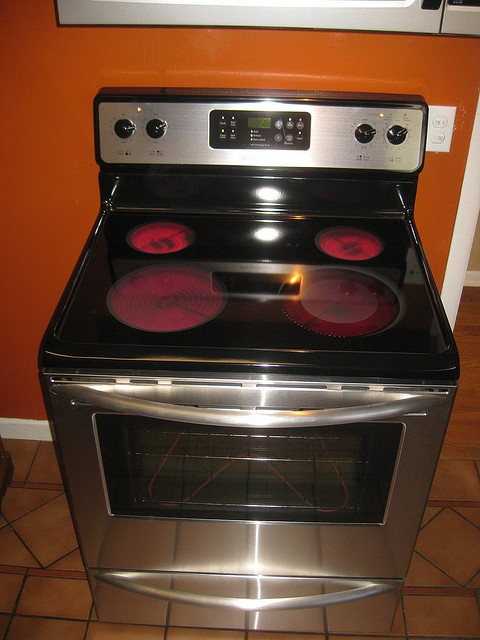Describe the objects in this image and their specific colors. I can see a oven in maroon, black, gray, and darkgray tones in this image. 